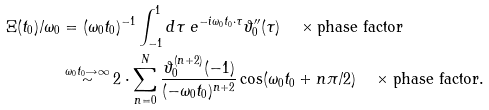<formula> <loc_0><loc_0><loc_500><loc_500>\Xi ( t _ { 0 } ) / \omega _ { 0 } & = ( \omega _ { 0 } t _ { 0 } ) ^ { - 1 } \int _ { - 1 } ^ { 1 } d \tau \ e ^ { - i \omega _ { 0 } t _ { 0 } \cdot \tau } \vartheta ^ { \prime \prime } _ { 0 } ( \tau ) \quad \times \text {phase factor} \\ & \stackrel { \omega _ { 0 } t _ { 0 } \rightarrow \infty } { \sim } 2 \cdot \sum _ { n = 0 } ^ { N } \frac { \vartheta _ { 0 } ^ { ( n + 2 ) } ( - 1 ) } { ( - \omega _ { 0 } t _ { 0 } ) ^ { n + 2 } } \cos ( \omega _ { 0 } t _ { 0 } + n \pi / 2 ) \quad \times \text {phase factor} .</formula> 